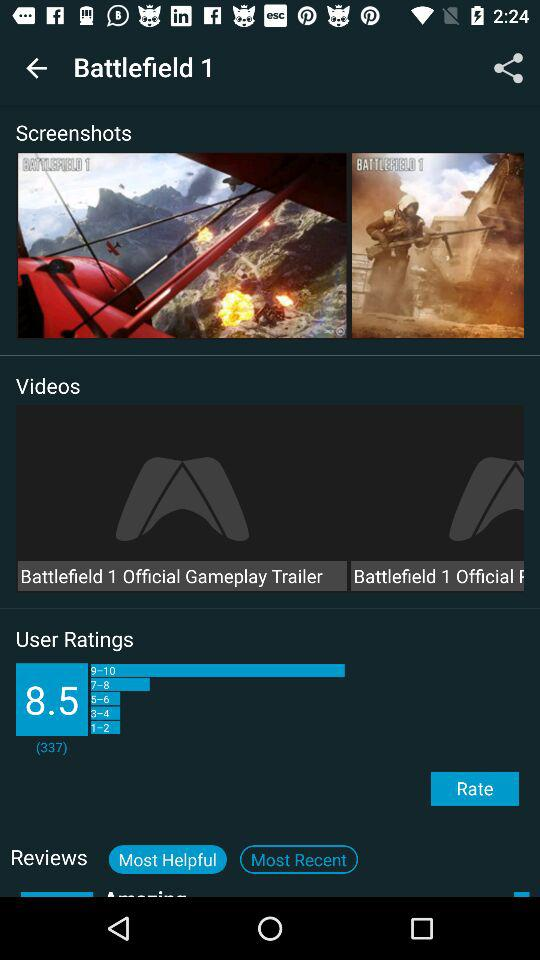Which tab is currently selected for reviews? The currently selected tab for reviews is "Most Helpful". 